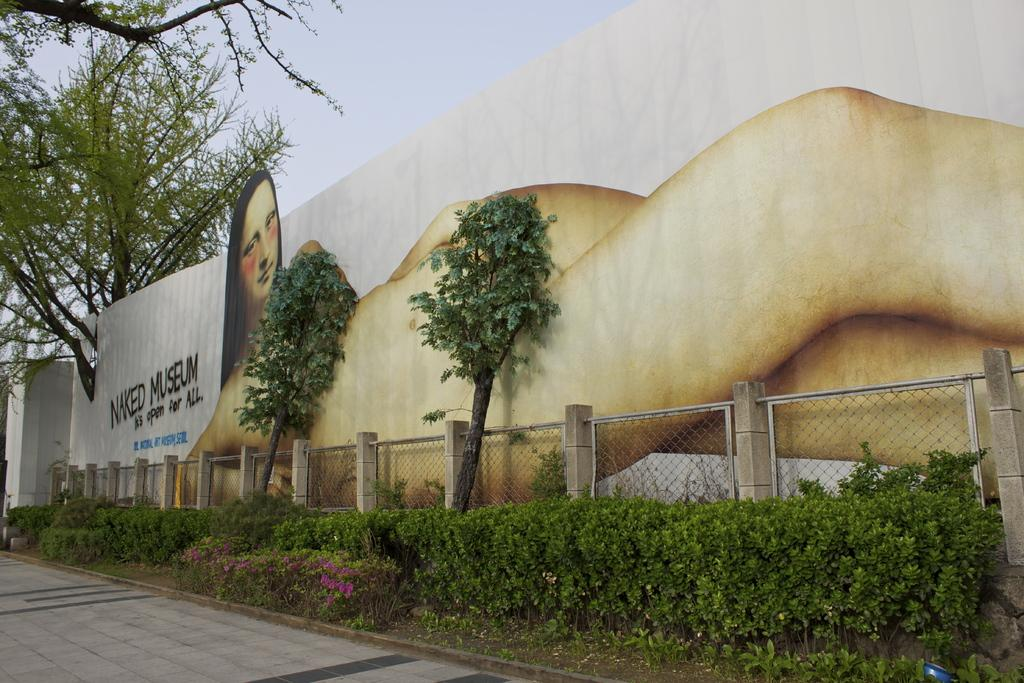What is depicted on the wall in the image? There is a painting on the wall in the image. What is written or displayed on the board in the image? There is a board with text in the image. What type of vegetation can be seen in the image? There are trees and plants in the image. What type of barrier is present in the image? There is fencing in the image. What type of surface is visible in the image? There is a pathway in the image. How many sisters are resting on the pathway in the image? There are no sisters or any indication of rest in the image. What type of footwear is visible on the people in the image? There are no people or footwear present in the image. 